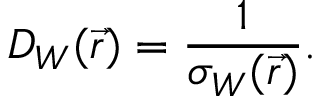Convert formula to latex. <formula><loc_0><loc_0><loc_500><loc_500>D _ { W } ( \vec { r } ) = \frac { 1 } { \sigma _ { W } ( \vec { r } ) } .</formula> 